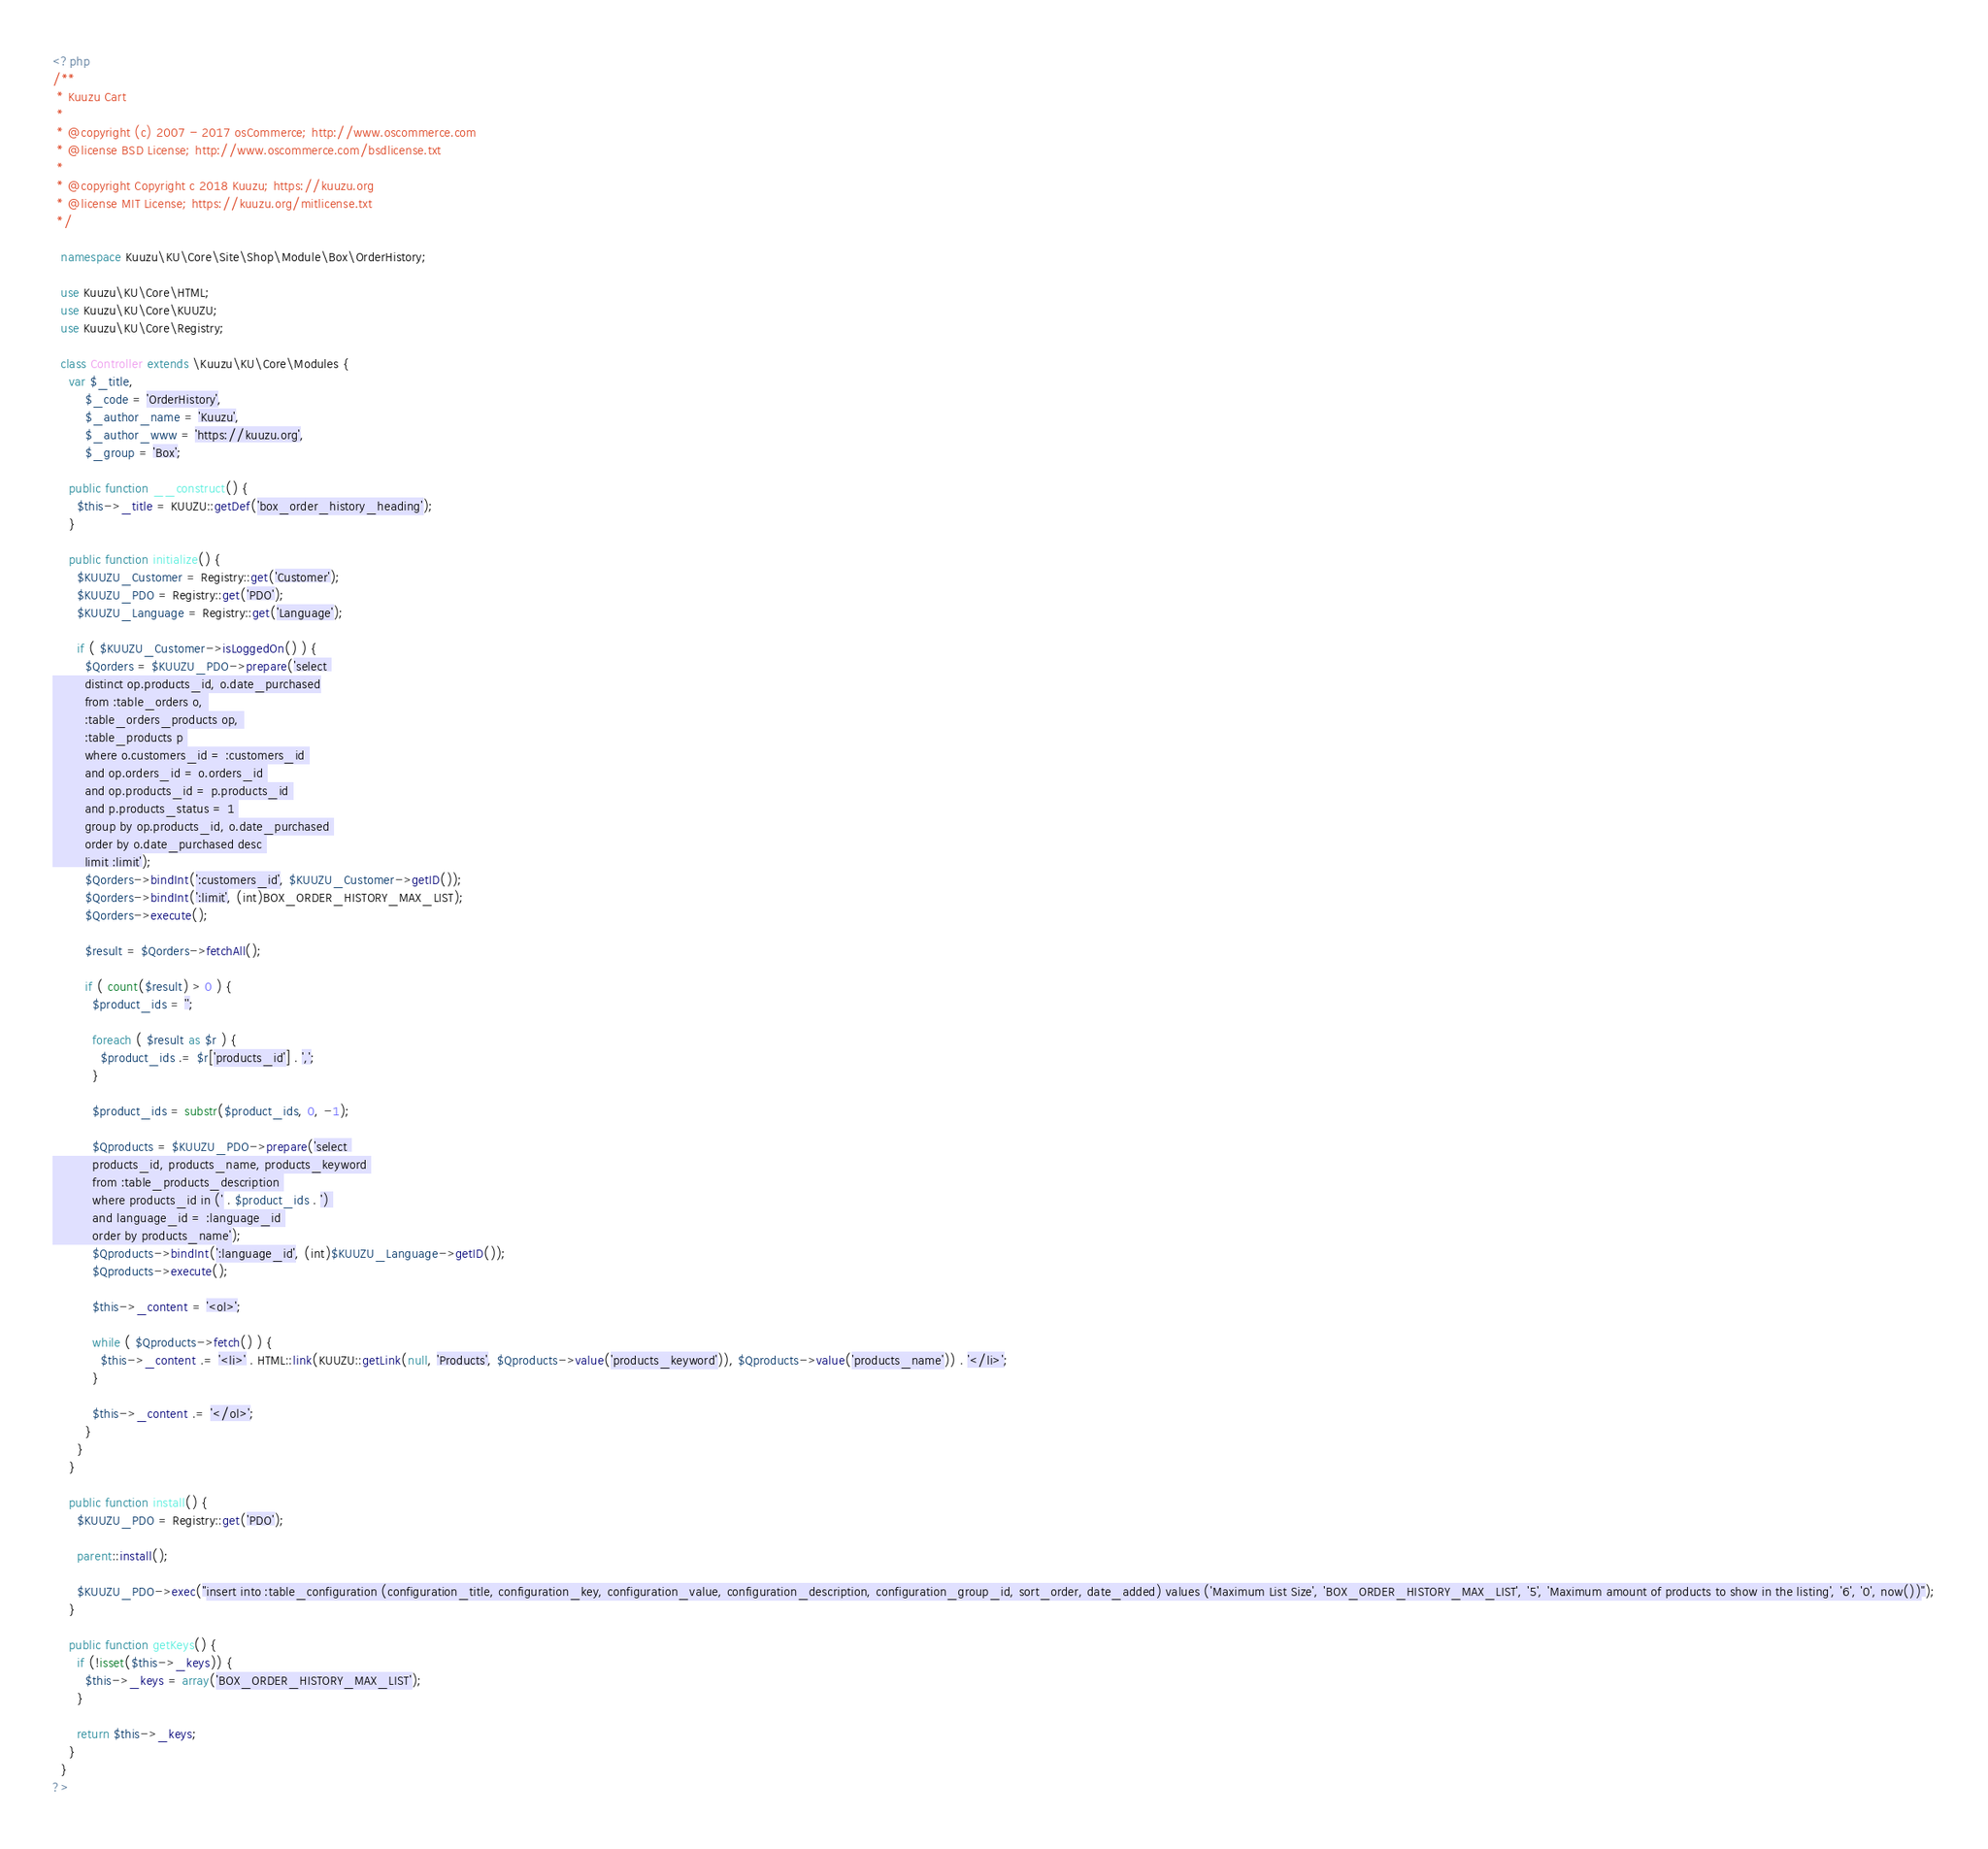<code> <loc_0><loc_0><loc_500><loc_500><_PHP_><?php
/**
 * Kuuzu Cart
 * 
 * @copyright (c) 2007 - 2017 osCommerce; http://www.oscommerce.com
 * @license BSD License; http://www.oscommerce.com/bsdlicense.txt
 *
 * @copyright Copyright c 2018 Kuuzu; https://kuuzu.org
 * @license MIT License; https://kuuzu.org/mitlicense.txt
 */

  namespace Kuuzu\KU\Core\Site\Shop\Module\Box\OrderHistory;

  use Kuuzu\KU\Core\HTML;
  use Kuuzu\KU\Core\KUUZU;
  use Kuuzu\KU\Core\Registry;
  
  class Controller extends \Kuuzu\KU\Core\Modules {
    var $_title,
        $_code = 'OrderHistory',
        $_author_name = 'Kuuzu',
        $_author_www = 'https://kuuzu.org',
        $_group = 'Box';

    public function __construct() {
      $this->_title = KUUZU::getDef('box_order_history_heading');
    }

    public function initialize() {
      $KUUZU_Customer = Registry::get('Customer');
      $KUUZU_PDO = Registry::get('PDO');
      $KUUZU_Language = Registry::get('Language');

      if ( $KUUZU_Customer->isLoggedOn() ) {
        $Qorders = $KUUZU_PDO->prepare('select 
        distinct op.products_id, o.date_purchased
        from :table_orders o, 
        :table_orders_products op, 
        :table_products p 
        where o.customers_id = :customers_id 
        and op.orders_id = o.orders_id 
        and op.products_id = p.products_id 
        and p.products_status = 1 
        group by op.products_id, o.date_purchased 
        order by o.date_purchased desc 
        limit :limit');
        $Qorders->bindInt(':customers_id', $KUUZU_Customer->getID());
        $Qorders->bindInt(':limit', (int)BOX_ORDER_HISTORY_MAX_LIST);
        $Qorders->execute();

        $result = $Qorders->fetchAll();

        if ( count($result) > 0 ) {
          $product_ids = '';

          foreach ( $result as $r ) {
            $product_ids .= $r['products_id'] . ',';
          }

          $product_ids = substr($product_ids, 0, -1);

          $Qproducts = $KUUZU_PDO->prepare('select 
          products_id, products_name, products_keyword 
          from :table_products_description 
          where products_id in (' . $product_ids . ') 
          and language_id = :language_id 
          order by products_name');
          $Qproducts->bindInt(':language_id', (int)$KUUZU_Language->getID());
          $Qproducts->execute();

          $this->_content = '<ol>';      
          
          while ( $Qproducts->fetch() ) {
            $this->_content .= '<li>' . HTML::link(KUUZU::getLink(null, 'Products', $Qproducts->value('products_keyword')), $Qproducts->value('products_name')) . '</li>';
          }
          
          $this->_content .= '</ol>';
        }
      }
    }

    public function install() {
      $KUUZU_PDO = Registry::get('PDO');

      parent::install();

      $KUUZU_PDO->exec("insert into :table_configuration (configuration_title, configuration_key, configuration_value, configuration_description, configuration_group_id, sort_order, date_added) values ('Maximum List Size', 'BOX_ORDER_HISTORY_MAX_LIST', '5', 'Maximum amount of products to show in the listing', '6', '0', now())");
    }

    public function getKeys() {
      if (!isset($this->_keys)) {
        $this->_keys = array('BOX_ORDER_HISTORY_MAX_LIST');
      }

      return $this->_keys;
    }
  }
?>
</code> 